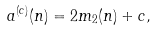Convert formula to latex. <formula><loc_0><loc_0><loc_500><loc_500>a ^ { ( c ) } ( n ) = 2 m _ { 2 } ( n ) + c ,</formula> 